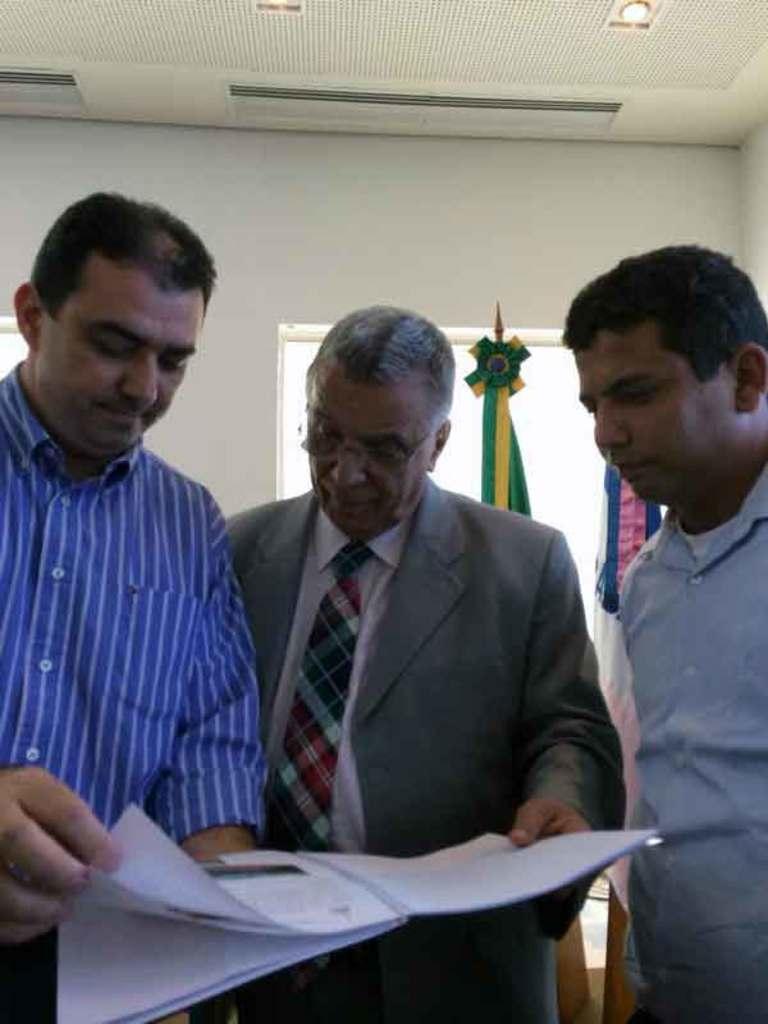Can you describe this image briefly? In the image there are three men standing and looking at a book and behind them there is window on the wall with ribbon on it and over the ceiling there are lights. 